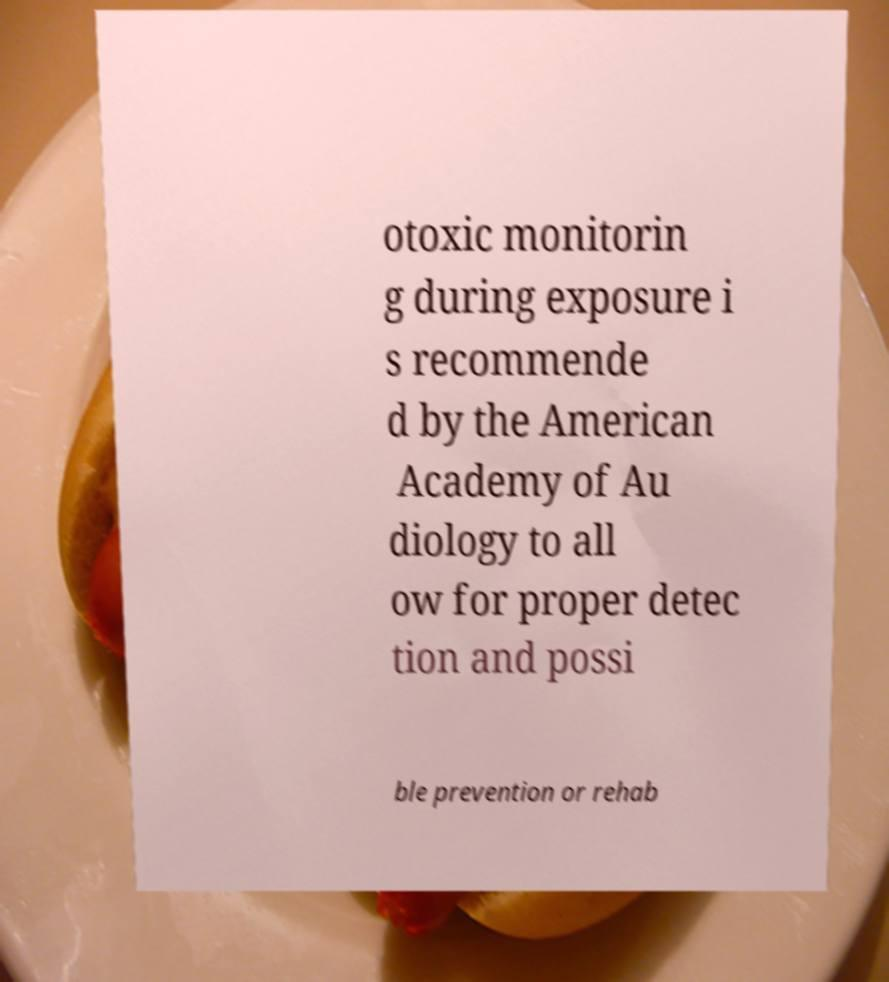Can you accurately transcribe the text from the provided image for me? otoxic monitorin g during exposure i s recommende d by the American Academy of Au diology to all ow for proper detec tion and possi ble prevention or rehab 